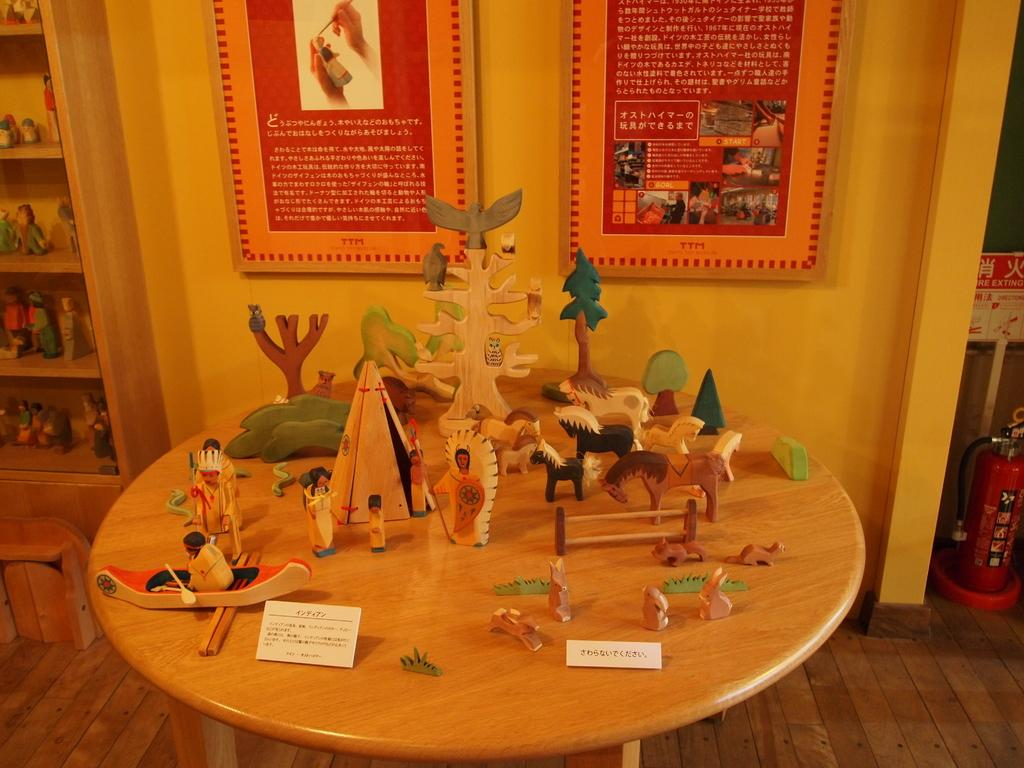What objects can be seen on the table in the image? There are toys on the table in the image. What is hanging on the wall in the image? There is a poster on the wall in the image. What is the rack in the image filled with? The rack is filled with toys in the image. What safety device is present in the image? There is a fire extinguisher in the image. What type of vein is used to sew the quilt in the image? There is no quilt or vein present in the image. What type of meal is being prepared on the table in the image? There is no meal preparation visible in the image; it features toys on the table. 